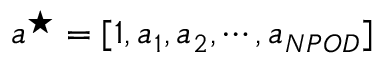<formula> <loc_0><loc_0><loc_500><loc_500>a ^ { ^ { * } } = [ 1 , a _ { 1 } , a _ { 2 } , \cdots , a _ { N P O D } ]</formula> 